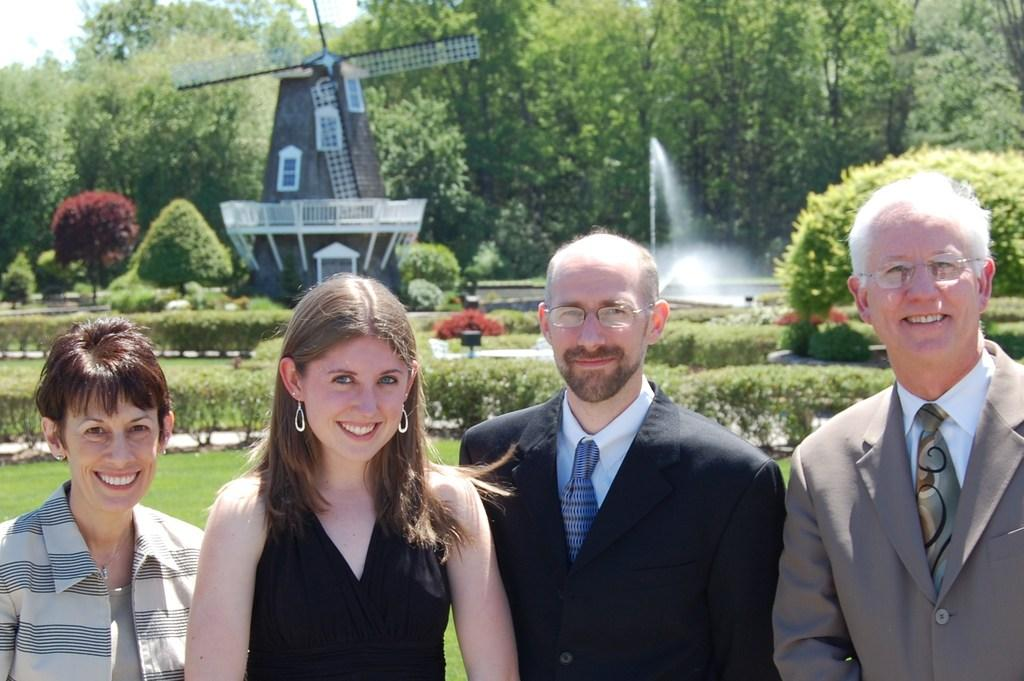How many people are in the image? There are four persons in the image. What is the facial expression of the people in the image? The persons are smiling. What type of vegetation can be seen in the image? There is grass, plants, and trees in the image. What is the architectural feature present in the image? There is a fountain in the image. What is visible in the background of the image? The sky is visible in the background of the image. Can you tell me how many times the toad jumps in the image? There is no toad present in the image, so it is not possible to determine how many times it jumps. 